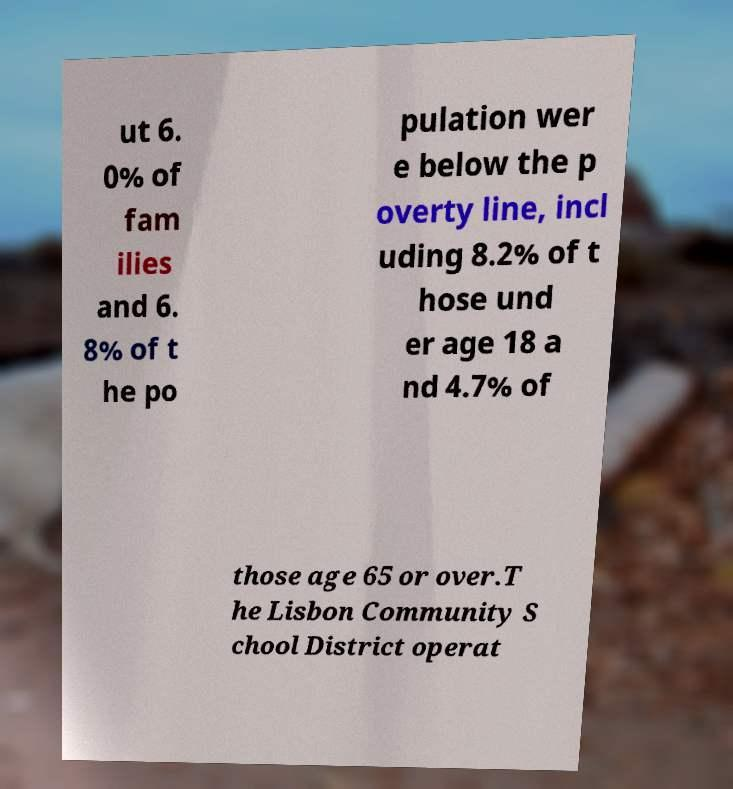Could you extract and type out the text from this image? ut 6. 0% of fam ilies and 6. 8% of t he po pulation wer e below the p overty line, incl uding 8.2% of t hose und er age 18 a nd 4.7% of those age 65 or over.T he Lisbon Community S chool District operat 